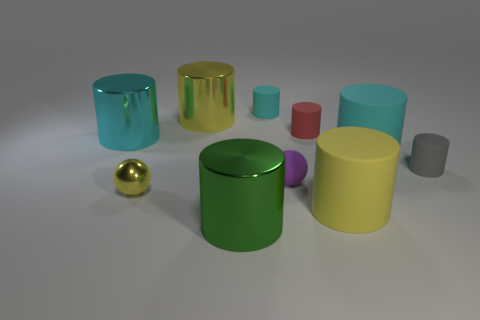Subtract all cyan cylinders. How many were subtracted if there are2cyan cylinders left? 1 Subtract all small cyan cylinders. How many cylinders are left? 7 Subtract all purple balls. How many balls are left? 1 Subtract 1 spheres. How many spheres are left? 1 Subtract 1 purple spheres. How many objects are left? 9 Subtract all spheres. How many objects are left? 8 Subtract all cyan balls. Subtract all yellow blocks. How many balls are left? 2 Subtract all brown spheres. How many yellow cylinders are left? 2 Subtract all tiny purple rubber balls. Subtract all big green metal things. How many objects are left? 8 Add 4 big cyan metal objects. How many big cyan metal objects are left? 5 